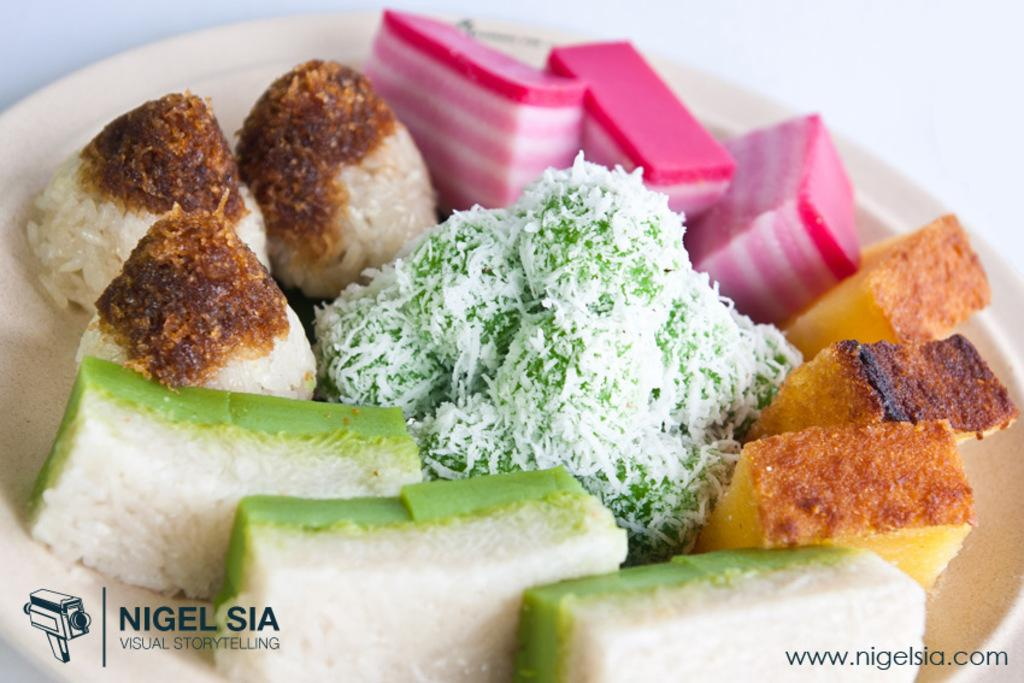What is present in the image related to food? There is food in the image. How is the food arranged or contained? The food is in a plate. Where is the plate with food located? The plate is placed on a table. What type of ice can be seen melting on the table in the image? There is no ice present in the image; it only features food in a plate on a table. 